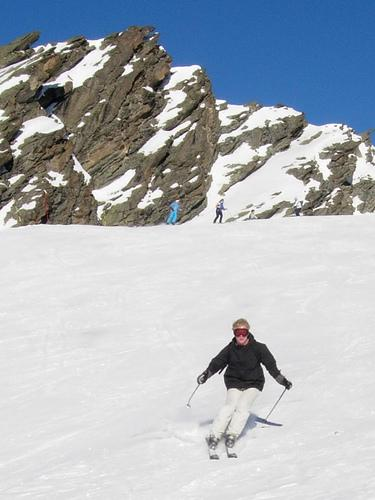What is the geological rock formation called?

Choices:
A) bump out
B) rock out
C) stick out
D) outcrop outcrop 